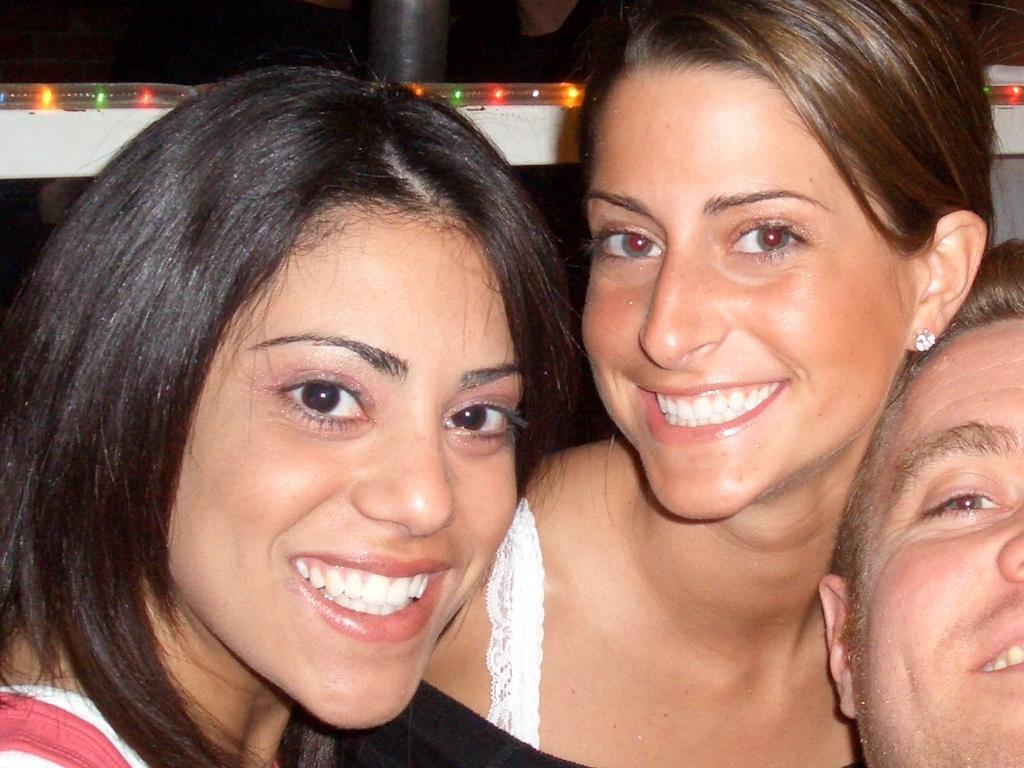Could you give a brief overview of what you see in this image? In this image we can see the persons sitting. And at the back we can see a pole and lights. 